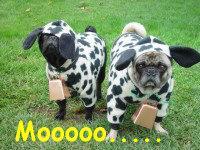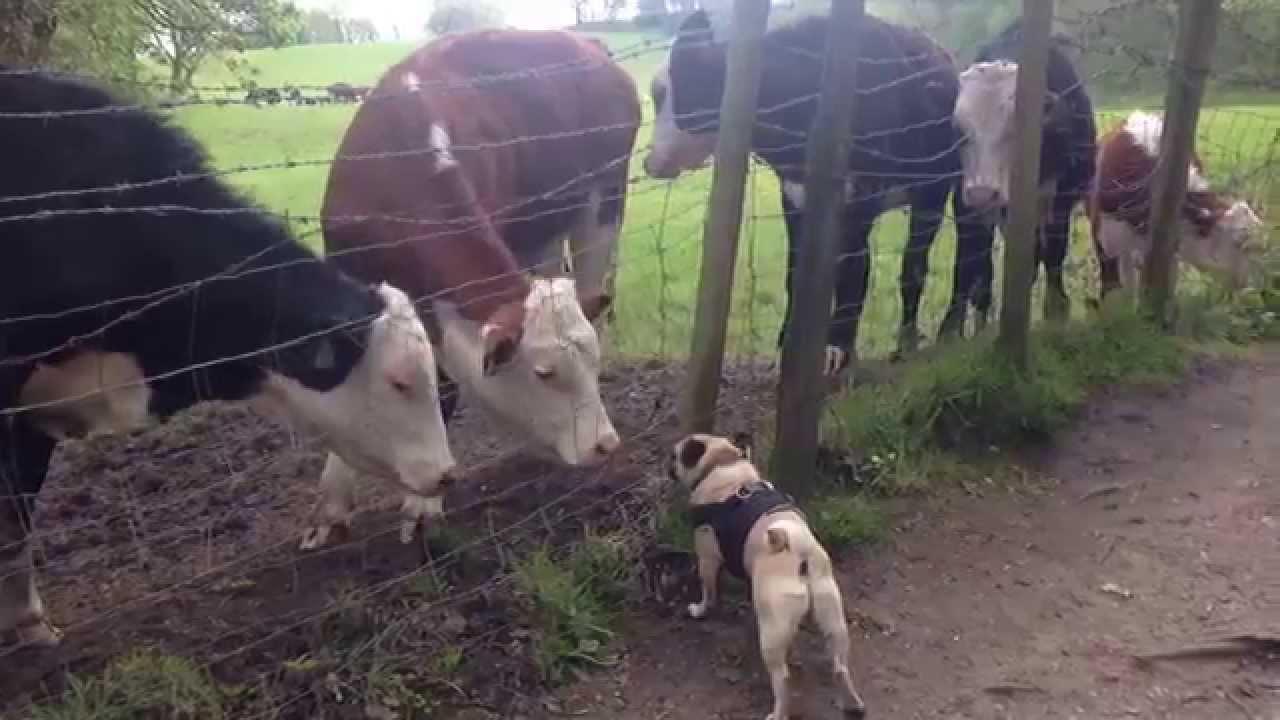The first image is the image on the left, the second image is the image on the right. Assess this claim about the two images: "The left image includes a dog wearing a black and white cow print costume.". Correct or not? Answer yes or no. Yes. The first image is the image on the left, the second image is the image on the right. For the images shown, is this caption "The dogs on the left are dressed like cows." true? Answer yes or no. Yes. 